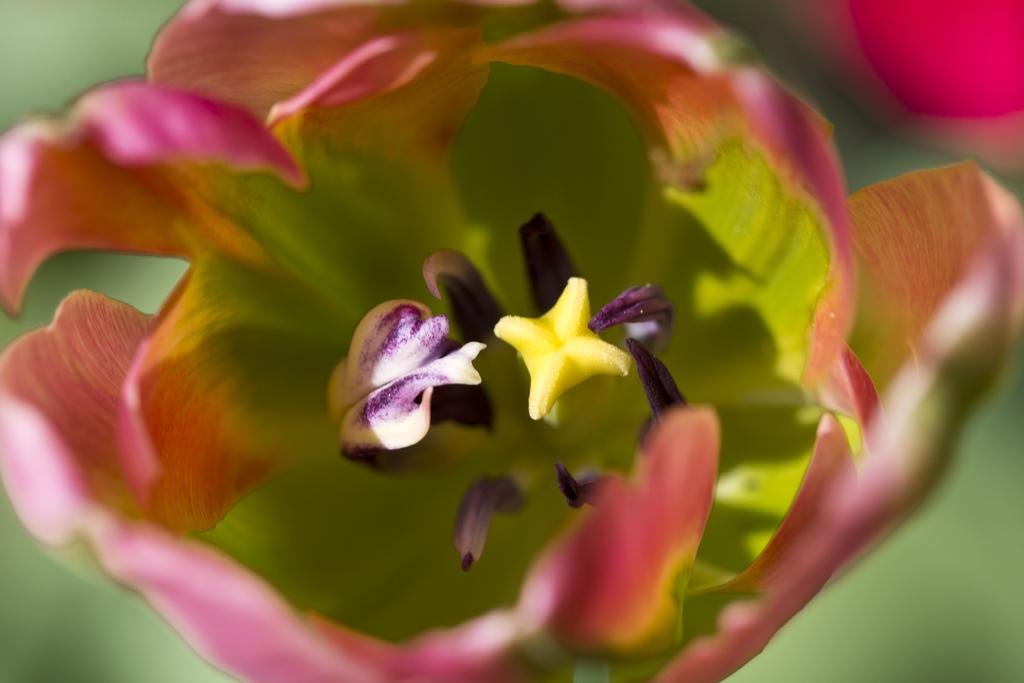What is the main subject of the image? The main subject of the image is a flower. Can you describe the flower in the image? The flower has different colors, including yellow, pink, violet, and red. Where is the cow sleeping in the image? There is no cow present in the image; it features a flower with different colors. 